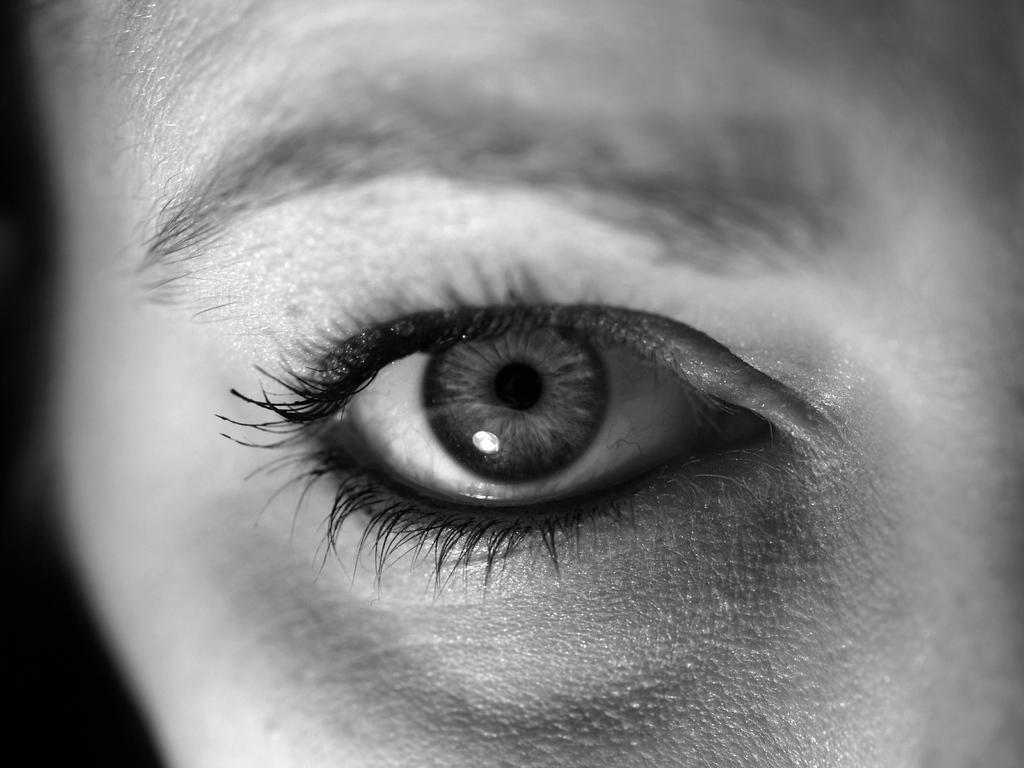What part of the human body is the main focus of the image? The main focus of the image is the eye of a person. What is located above the eye in the image? There is an eyebrow above the eye in the image. How much money is floating in the ocean in the image? There is no ocean or money present in the image; it only features an eye and an eyebrow. 